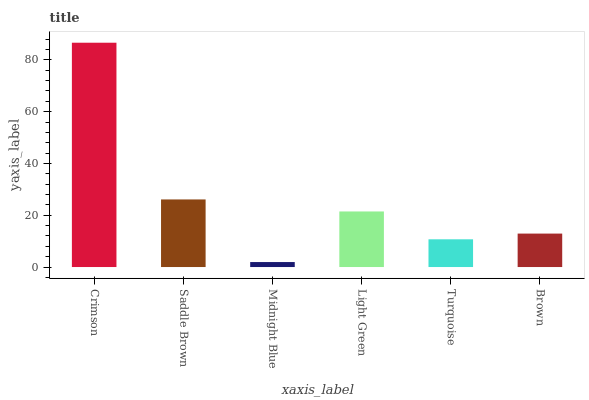Is Midnight Blue the minimum?
Answer yes or no. Yes. Is Crimson the maximum?
Answer yes or no. Yes. Is Saddle Brown the minimum?
Answer yes or no. No. Is Saddle Brown the maximum?
Answer yes or no. No. Is Crimson greater than Saddle Brown?
Answer yes or no. Yes. Is Saddle Brown less than Crimson?
Answer yes or no. Yes. Is Saddle Brown greater than Crimson?
Answer yes or no. No. Is Crimson less than Saddle Brown?
Answer yes or no. No. Is Light Green the high median?
Answer yes or no. Yes. Is Brown the low median?
Answer yes or no. Yes. Is Turquoise the high median?
Answer yes or no. No. Is Turquoise the low median?
Answer yes or no. No. 